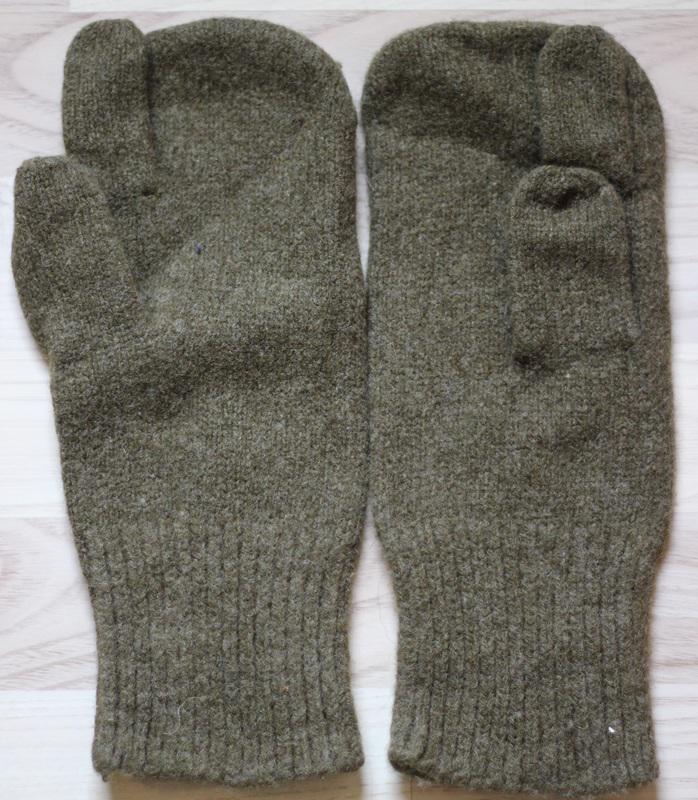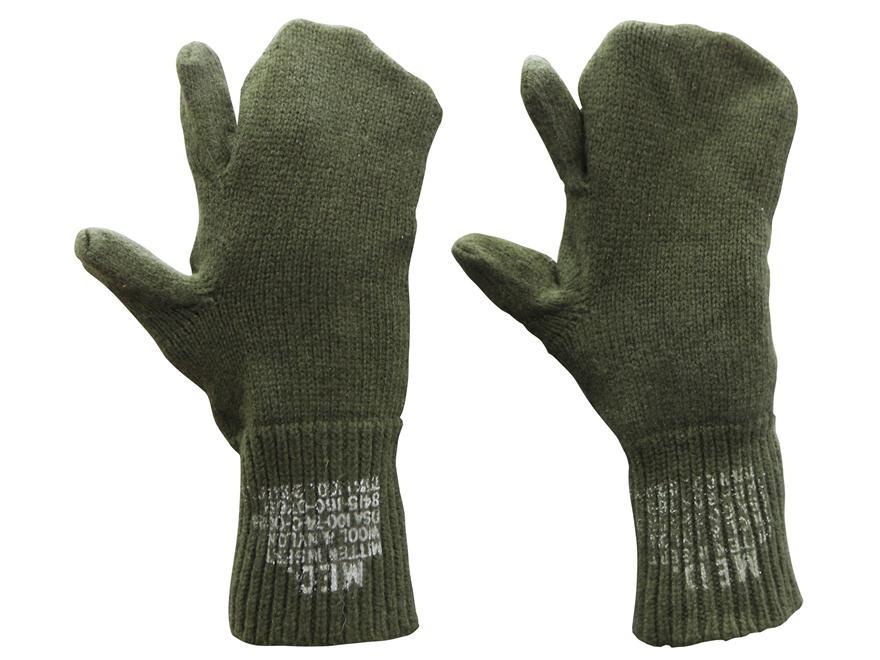The first image is the image on the left, the second image is the image on the right. Evaluate the accuracy of this statement regarding the images: "Only the right image shows mittens with a diamond pattern.". Is it true? Answer yes or no. No. 